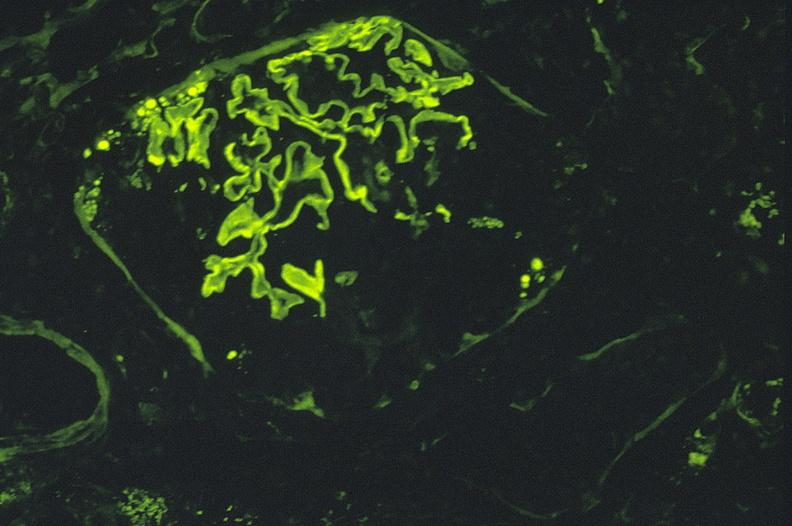what does this image show?
Answer the question using a single word or phrase. Antiglomerlar basement membrane 